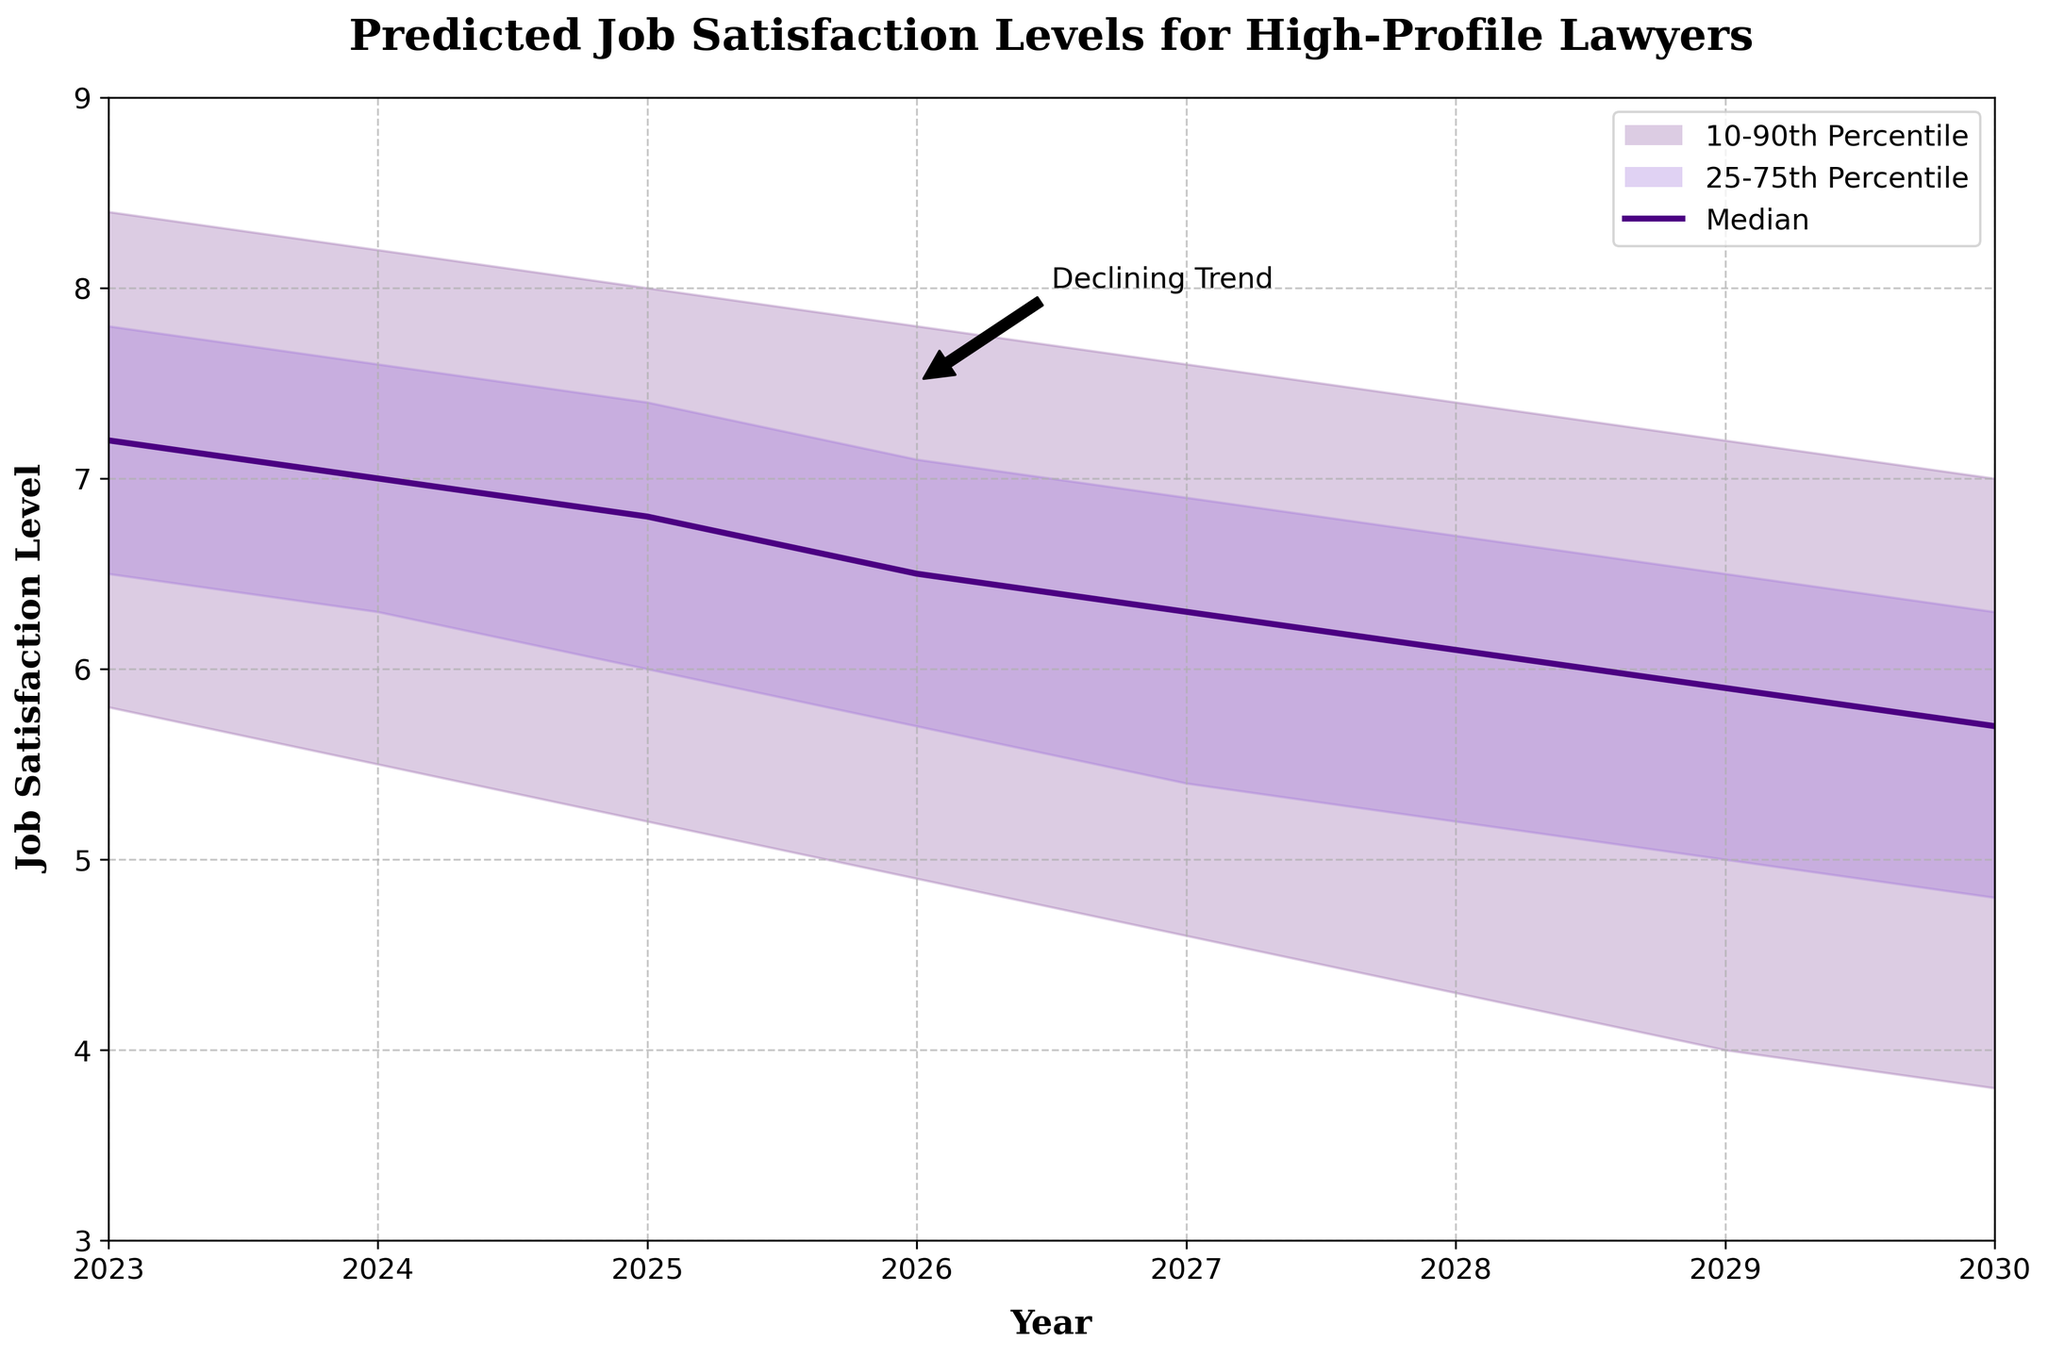What is the title of the chart? The title is located at the top of the chart and provides a brief description of what the chart depicts. According to the provided code, the title of the chart is "Predicted Job Satisfaction Levels for High-Profile Lawyers."
Answer: Predicted Job Satisfaction Levels for High-Profile Lawyers What is the median job satisfaction level predicted for the year 2025? Locate the median line for the year 2025, which is typically represented as a central line or the middle value in the data. According to the data, the median value for 2025 is 6.8.
Answer: 6.8 How does the job satisfaction level change from 2023 to 2030? Observe the general trend of the median line from the years 2023 to 2030. The median job satisfaction level starts at 7.2 in 2023 and declines to 5.7 by 2030.
Answer: It declines What is the range of job satisfaction levels for the year 2027 based on the 10th and 90th percentiles? For the year 2027, identify the values at the 10th and 90th percentiles. According to the data, these values are 4.6 and 7.6, respectively. The range is found by subtracting the 10th percentile from the 90th percentile (7.6 - 4.6).
Answer: 3.0 In which year is the predicted median job satisfaction level the highest? Compare the median job satisfaction levels across all years. According to the data, the highest median level is in 2023, with a value of 7.2.
Answer: 2023 Which year shows the lowest value at the 10th percentile? Look at the 10th percentile values for each year and determine which is the lowest. According to the data, the lowest 10th percentile value is in 2030, which is 3.8.
Answer: 2030 Examine the plot and determine the general trend indicated by the annotation "Declining Trend." The annotation is placed near the year 2026, pointing to a general downward trend in job satisfaction levels. The plot shows that the median job satisfaction level, along with the percentiles, decreases over the years, supporting the annotation.
Answer: Downward trend What is the difference between the upper 90th percentile and the lower 10th percentile in 2028? Find the values of the upper 90th and lower 10th percentiles for the year 2028. According to the data, these values are 7.4 and 4.3, respectively. The difference is calculated by subtracting the lower 10th percentile from the upper 90th percentile (7.4 - 4.3).
Answer: 3.1 Between which years is there a noticeable sharp decline in the median job satisfaction level? Examine the slope of the median line over different periods. A sharp decline is observed between 2026 and 2027, where the median drops from 6.5 to 6.3.
Answer: 2026 and 2027 